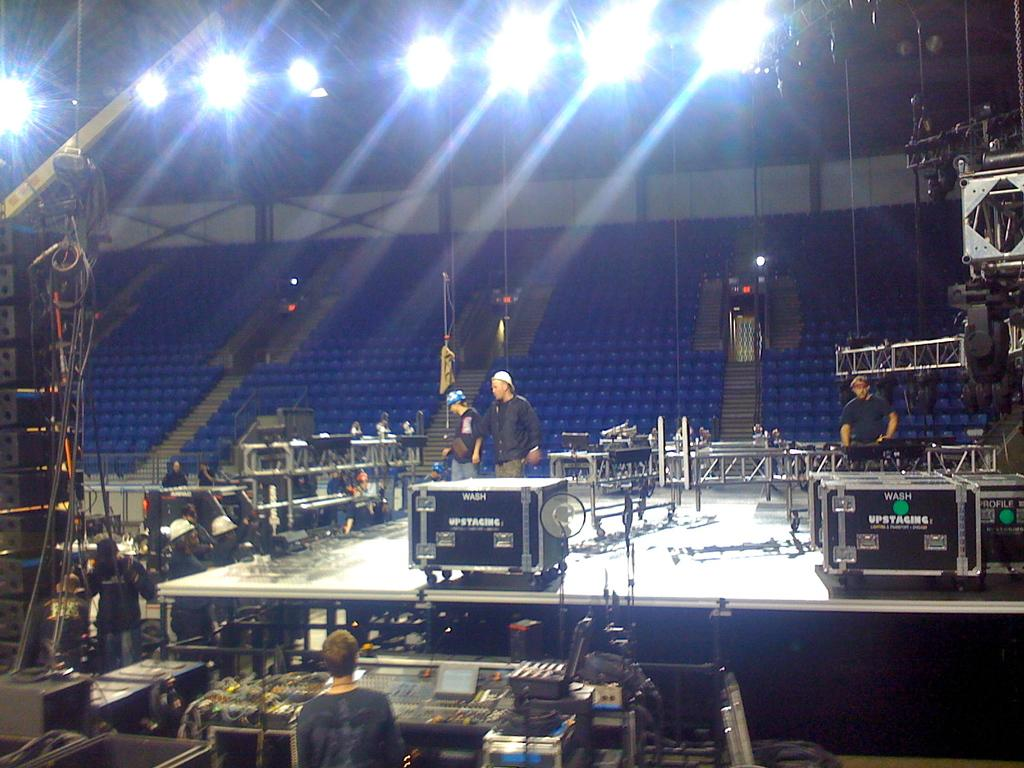Who or what can be seen in the image? There are people in the image. What else is present in the image besides people? There are devices, cables, a stage, focusing lights, and chairs visible in the image. Can you describe the devices in the image? The devices in the image are not specified, but they are likely related to the stage and performance. What is the purpose of the focusing lights in the image? The focusing lights in the background of the image are likely used to illuminate the stage and performers. What type of liquid is being poured on the stage in the image? There is no liquid being poured on the stage in the image; it is a performance setting with people, devices, cables, a stage, focusing lights, and chairs. 